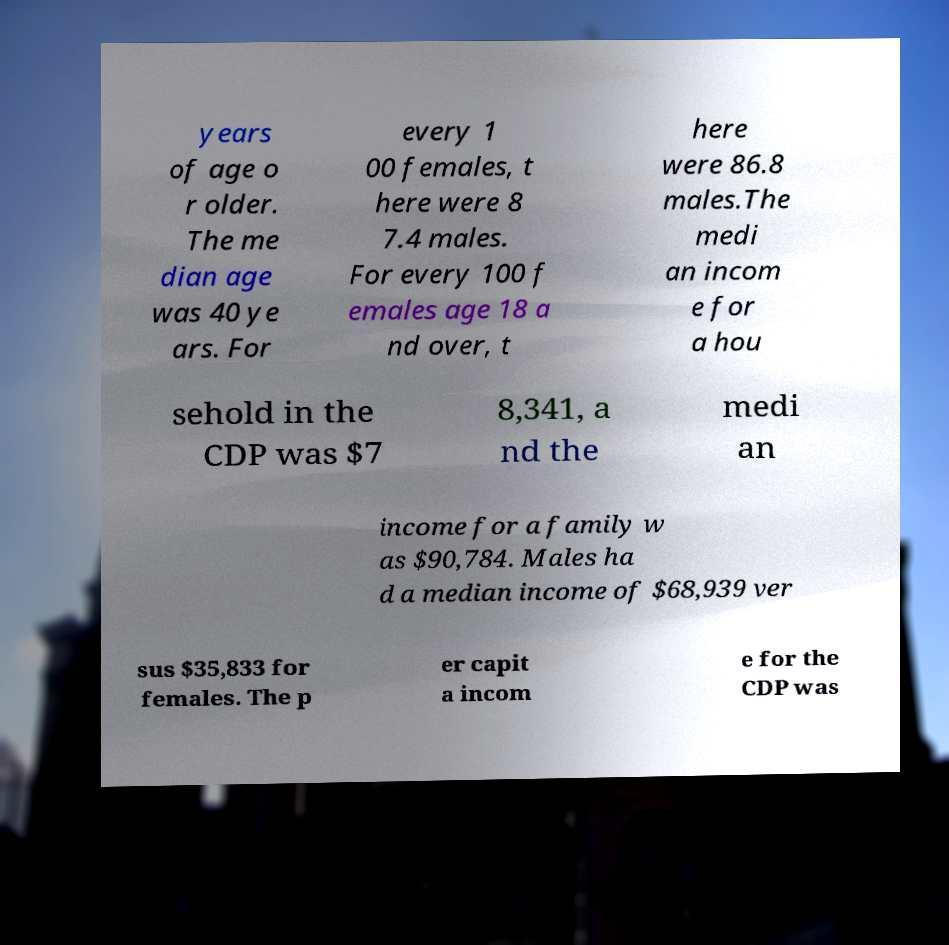What messages or text are displayed in this image? I need them in a readable, typed format. years of age o r older. The me dian age was 40 ye ars. For every 1 00 females, t here were 8 7.4 males. For every 100 f emales age 18 a nd over, t here were 86.8 males.The medi an incom e for a hou sehold in the CDP was $7 8,341, a nd the medi an income for a family w as $90,784. Males ha d a median income of $68,939 ver sus $35,833 for females. The p er capit a incom e for the CDP was 